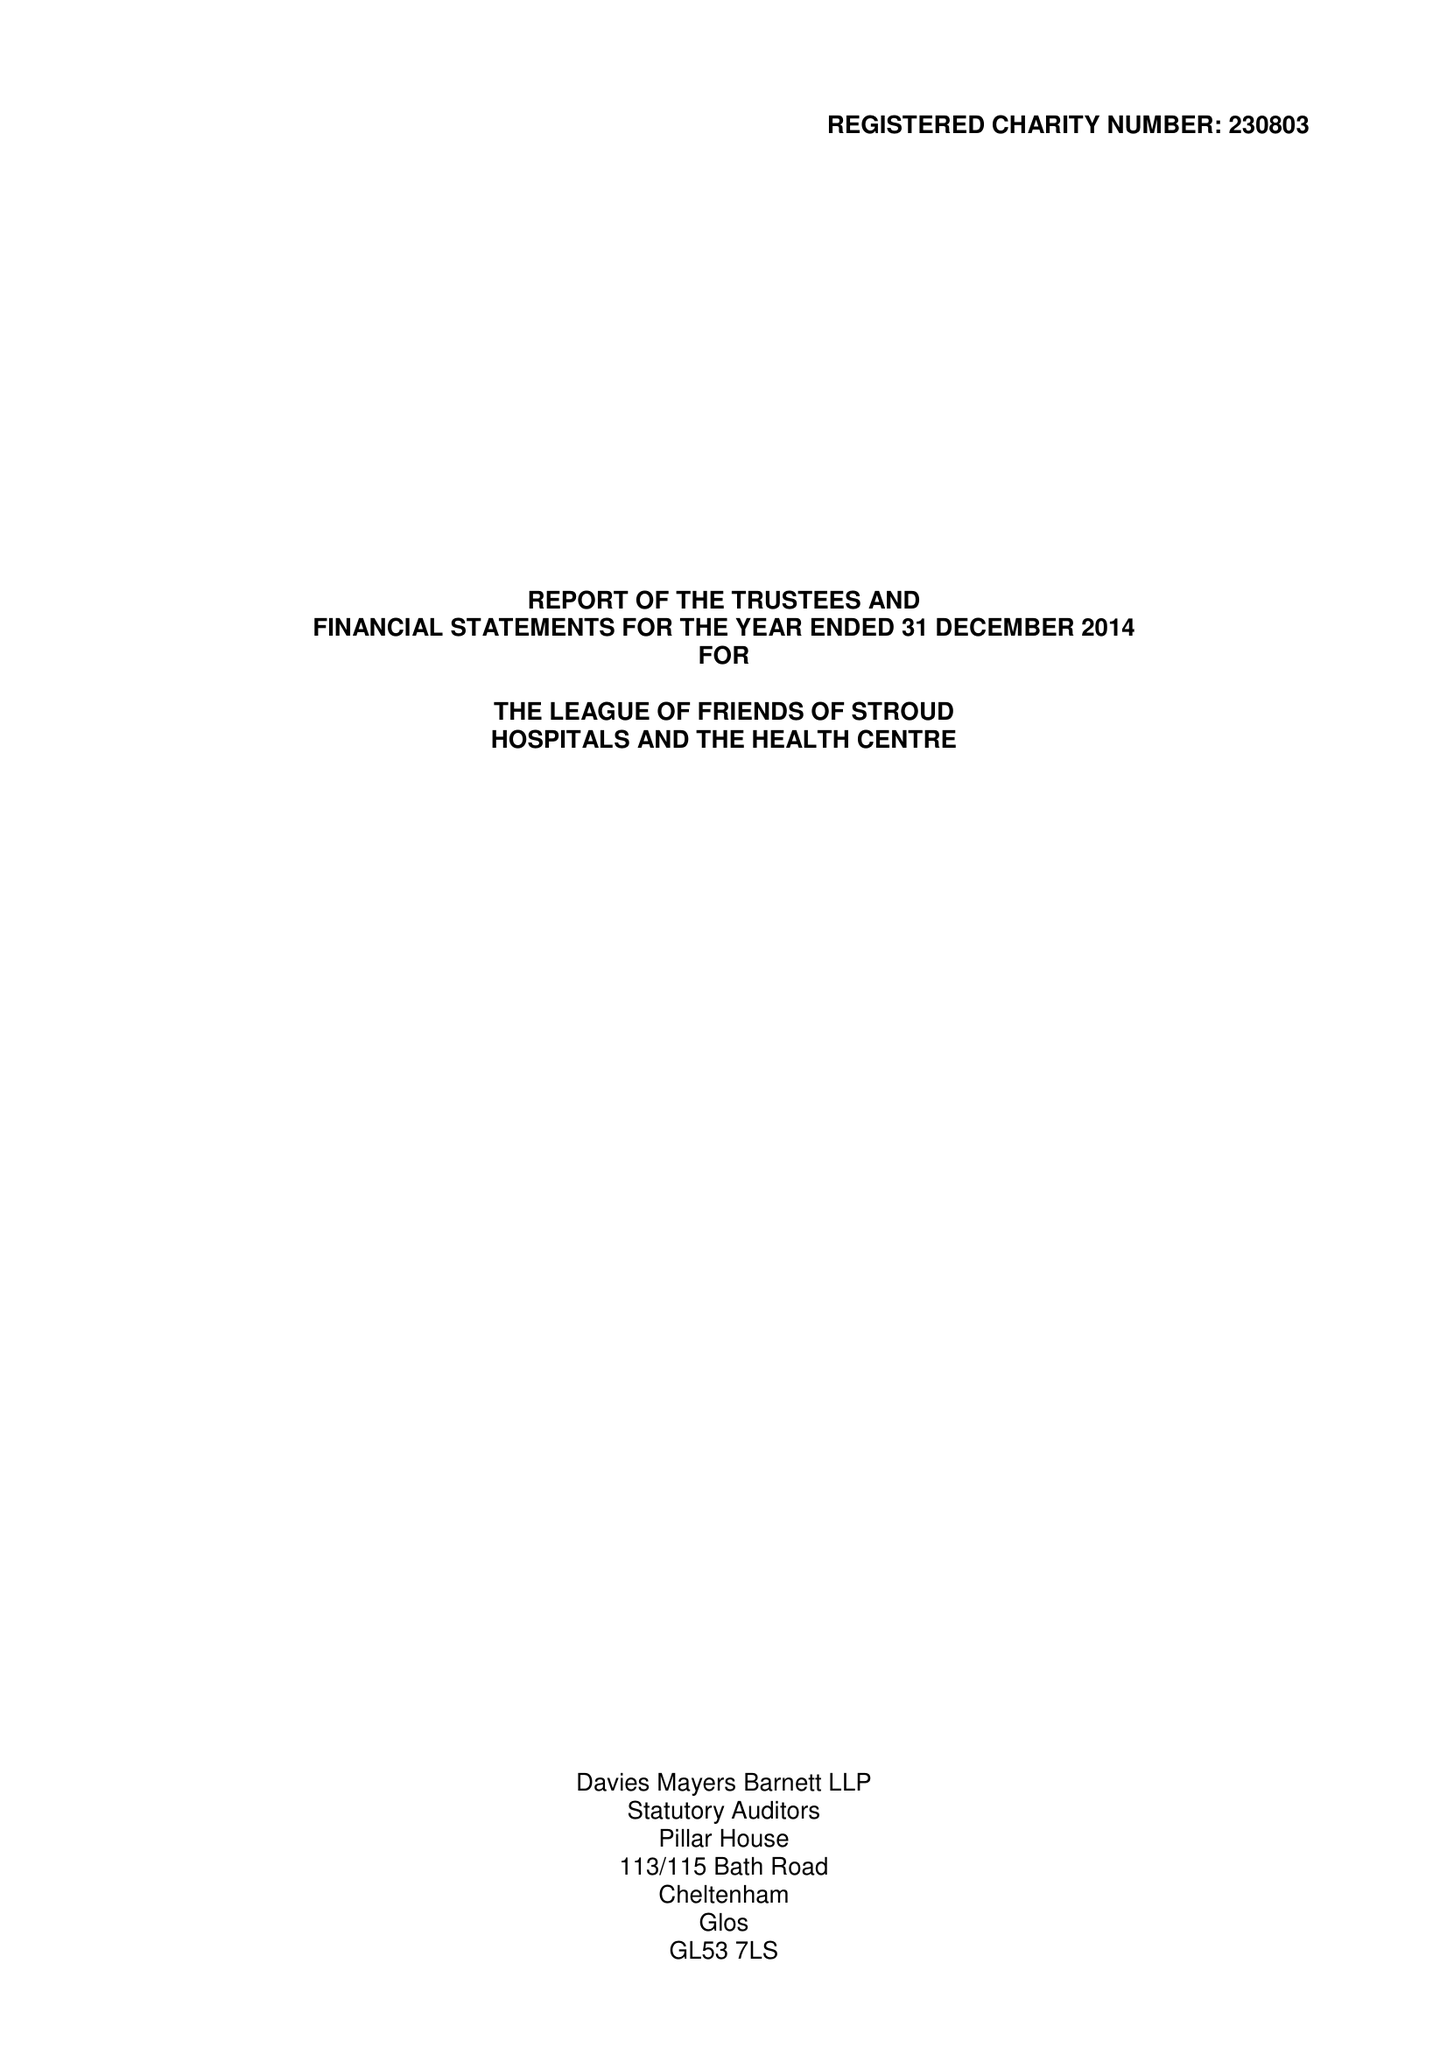What is the value for the income_annually_in_british_pounds?
Answer the question using a single word or phrase. 80065.00 